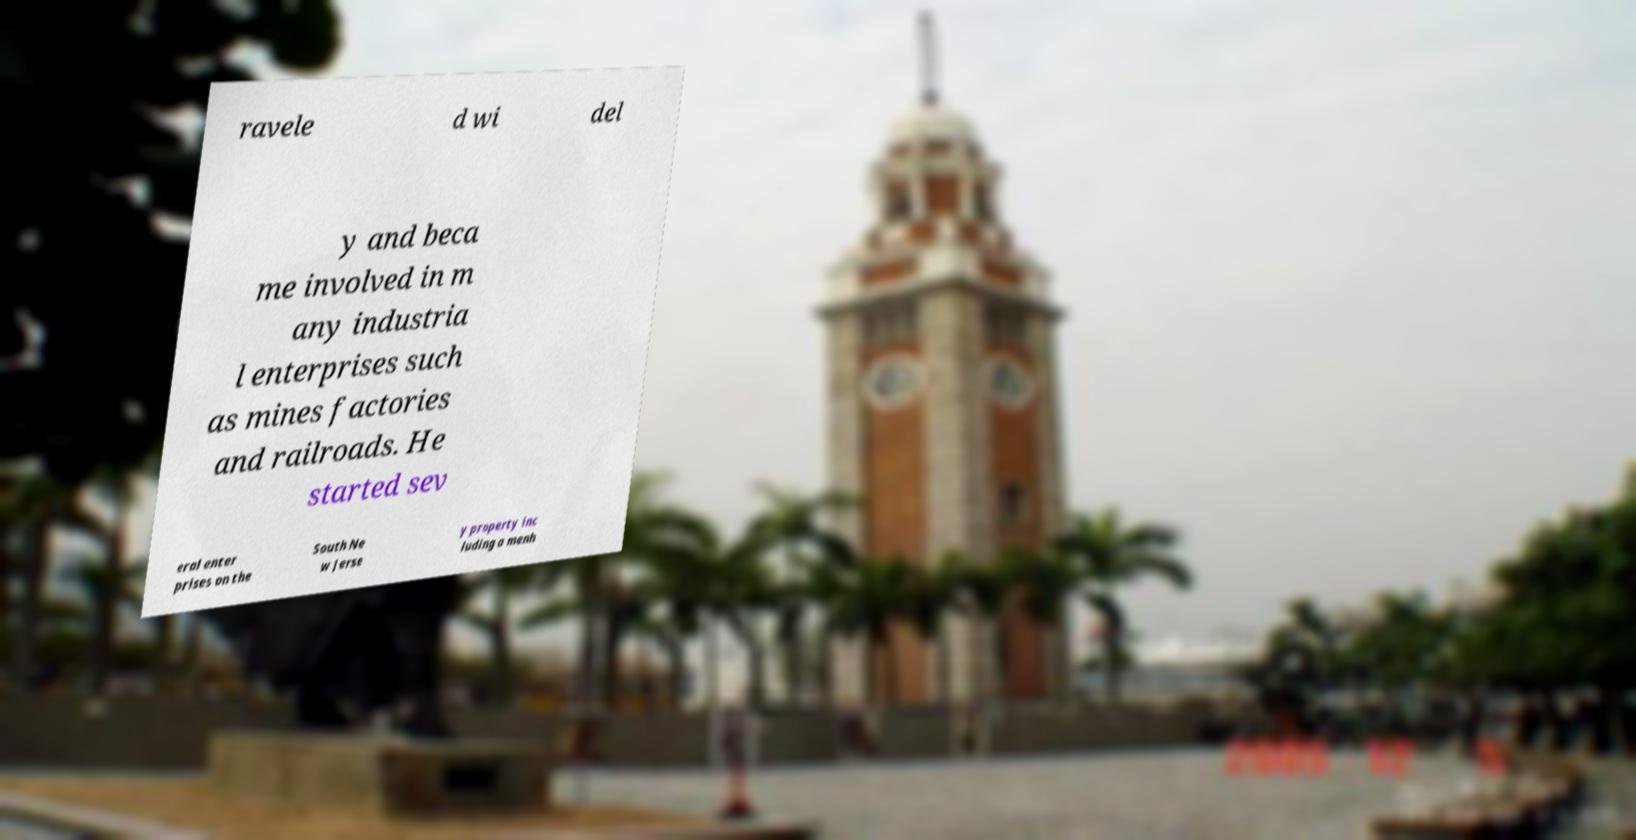Please identify and transcribe the text found in this image. ravele d wi del y and beca me involved in m any industria l enterprises such as mines factories and railroads. He started sev eral enter prises on the South Ne w Jerse y property inc luding a menh 